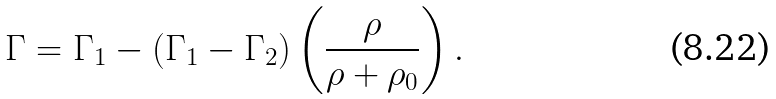<formula> <loc_0><loc_0><loc_500><loc_500>\Gamma = \Gamma _ { 1 } - ( \Gamma _ { 1 } - \Gamma _ { 2 } ) \left ( \frac { \rho } { \rho + \rho _ { 0 } } \right ) .</formula> 